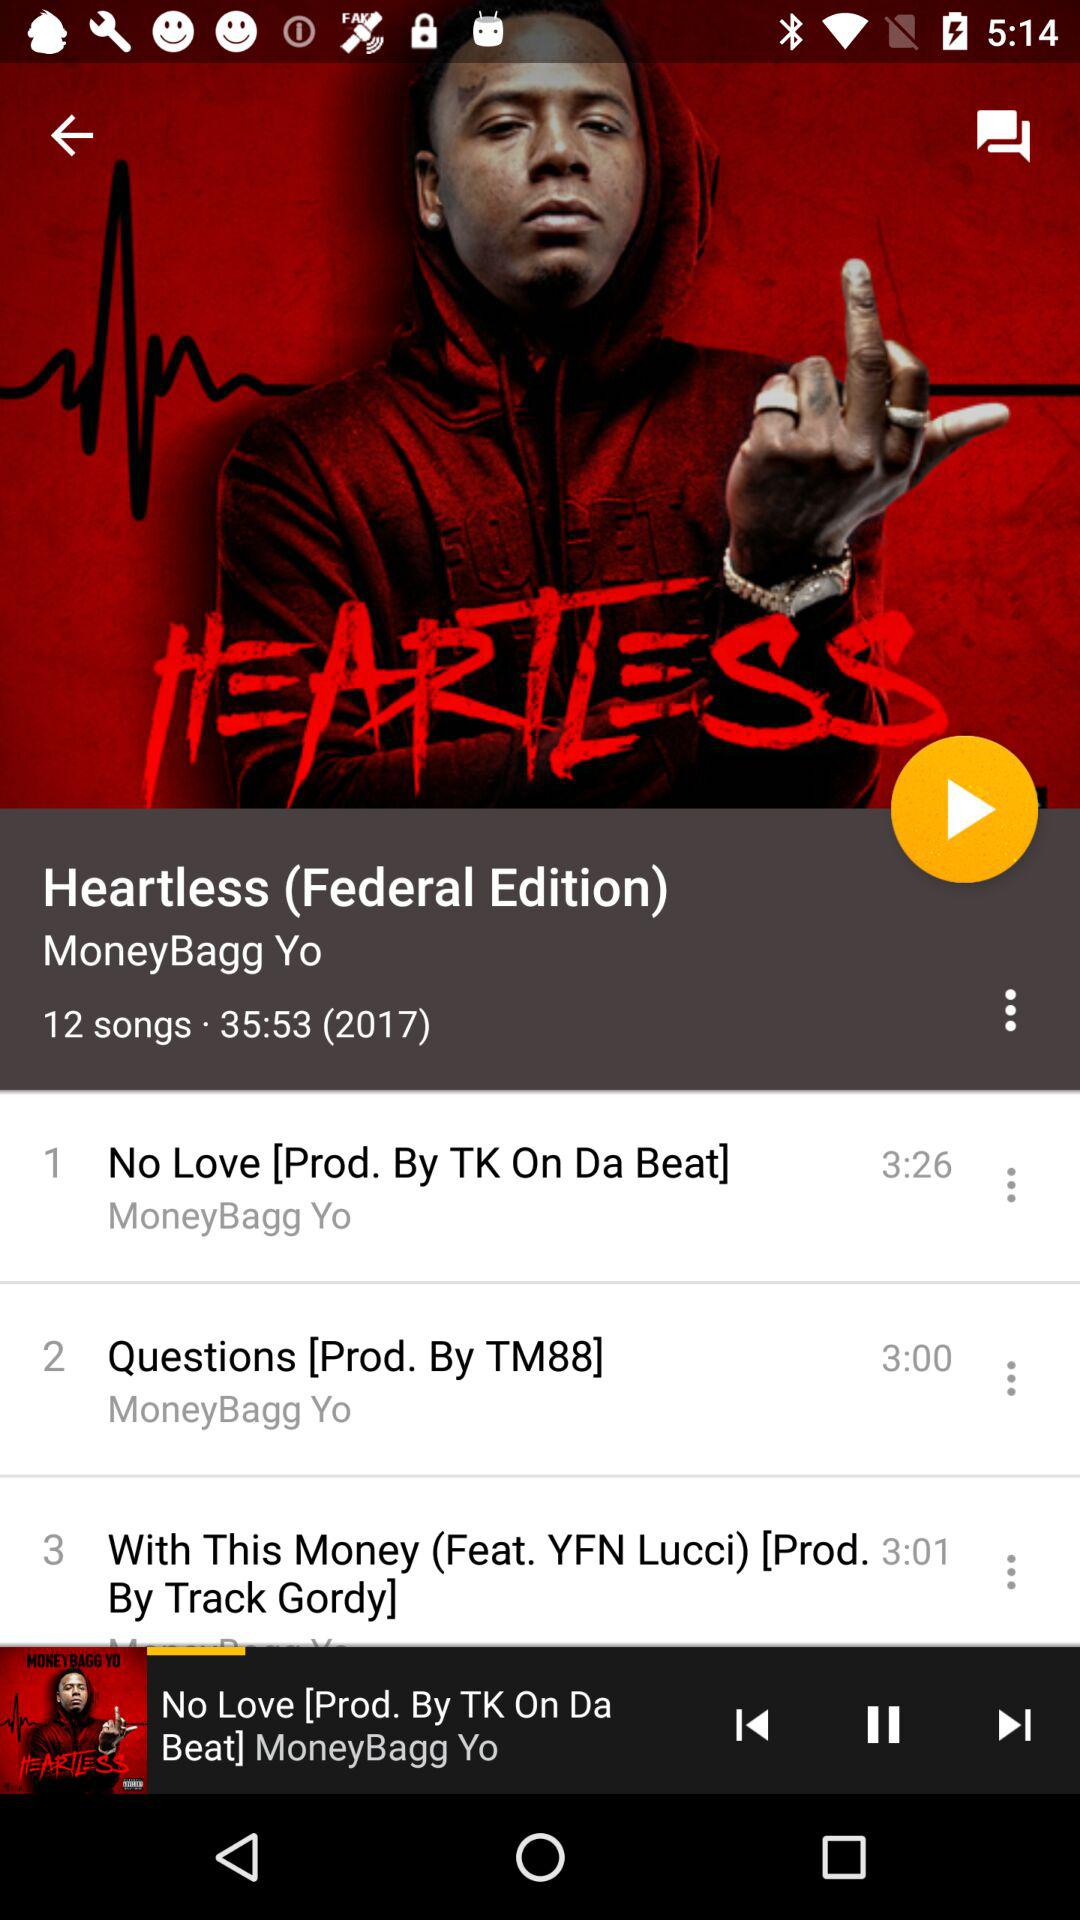What is the total number of songs in the album? The total number of songs in the album is 12. 